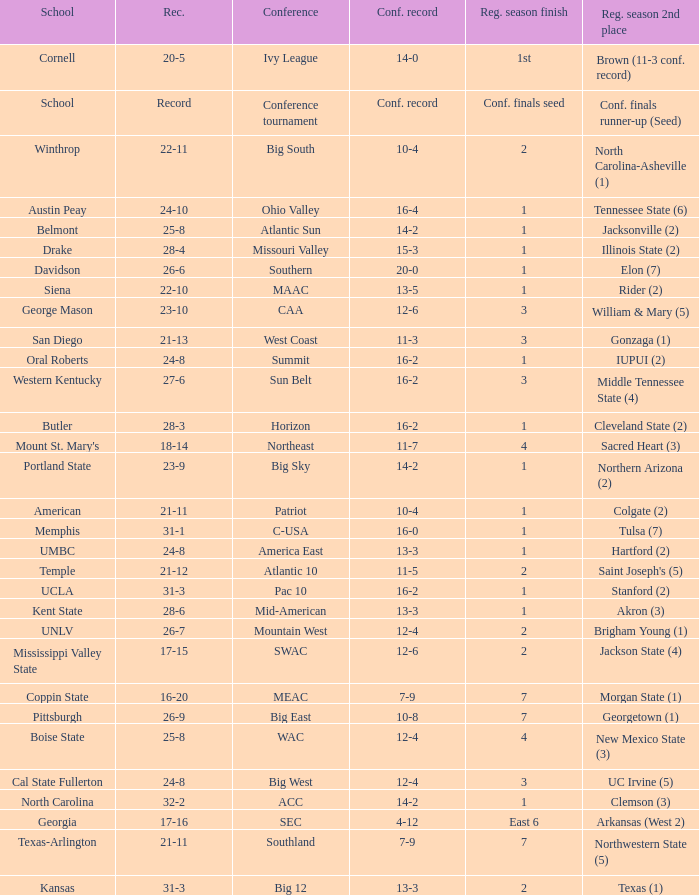Which conference is Belmont in? Atlantic Sun. 